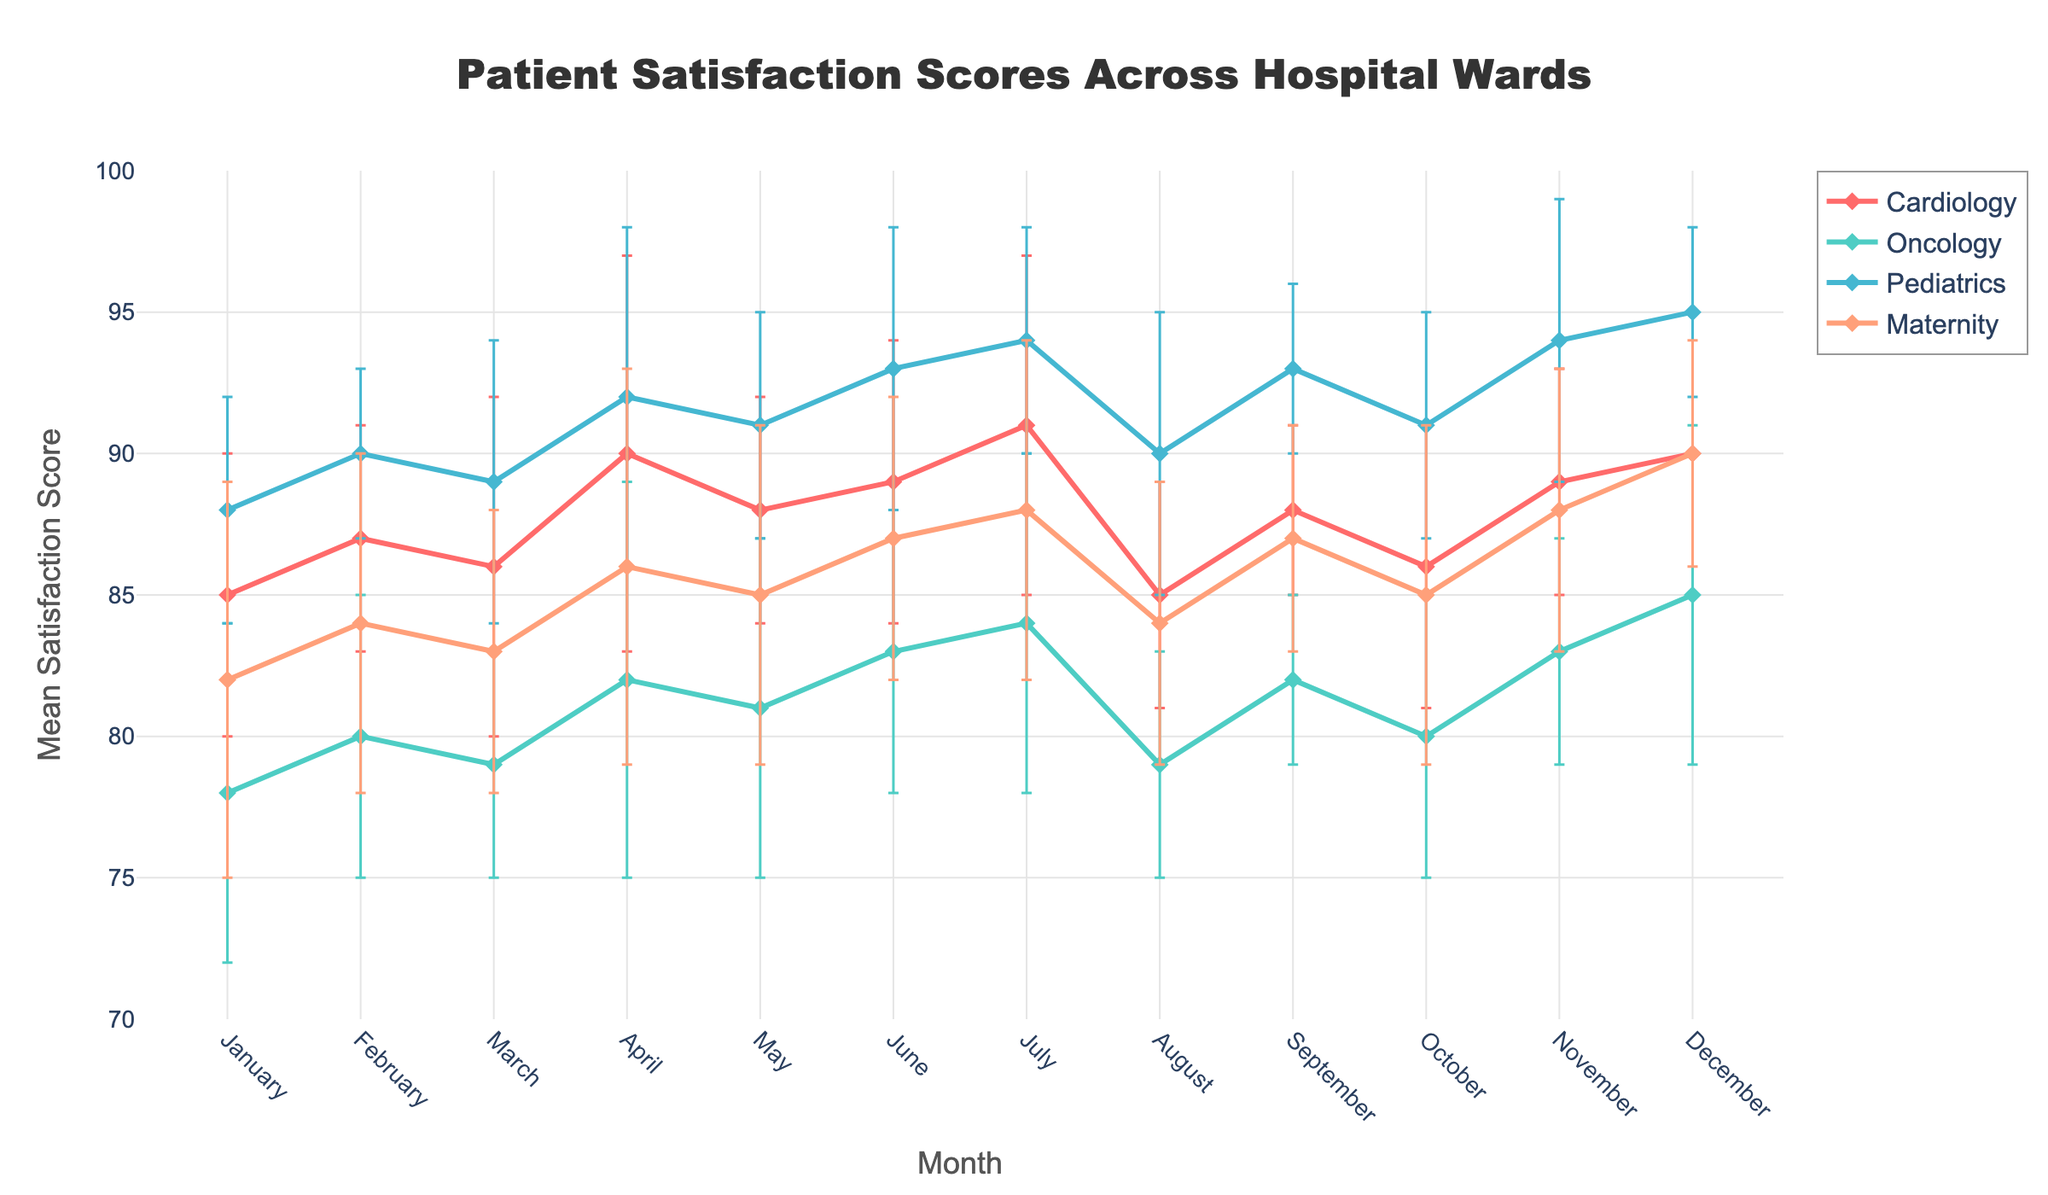Which ward has the highest mean satisfaction score in December? The figure clearly shows the mean satisfaction scores across different wards for each month. For December, compare the mean satisfaction scores for Cardiology, Oncology, Pediatrics, and Maternity.
Answer: Pediatrics What is the range of the y-axis? The y-axis represents the mean satisfaction score. Checking the y-axis reveals the scale is set from 70 to 100.
Answer: 70 to 100 Does any ward have an increasing trend in satisfaction scores over the months? Looking at the plot lines for each ward, notice the general trend of the satisfaction scores. Pediatrics and Maternity both show an upward trend throughout the year.
Answer: Pediatrics, Maternity Which month does Cardiology have the highest mean satisfaction score, and what is it? Observe the data points for Cardiology across all months. The highest point for mean satisfaction in Cardiology occurs in July, with a score of 91.
Answer: July, 91 Compare the mean satisfaction scores for Oncology and Maternity in April. Which ward has a higher score? Find the data points for Oncology and Maternity in April. Oncology has a score of 82, while Maternity has a score of 86.
Answer: Maternity What is the standard deviation for Pediatrics in September? Locate the error bar for Pediatrics in September. The length of the error bar corresponds to the standard deviation, which is 3 in this case.
Answer: 3 Which ward shows the greatest variability in satisfaction scores in January, and what is the standard deviation? Examine the lengths of the error bars for all wards in January. The longest error bar indicates the greatest variability. Maternity has the greatest variability with a standard deviation of 7.
Answer: Maternity, 7 Calculate the average mean satisfaction score for Maternity over the year. Sum the mean satisfaction scores of Maternity for each month and divide by 12: (82+84+83+86+85+87+88+84+87+85+88+90) / 12 = 86.
Answer: 86 Is there any overlap in the error bars of Cardiology and Pediatrics in any month? If so, in which month(s)? Review the error bars for Cardiology and Pediatrics each month to see if they overlap. They overlap in August and October.
Answer: August, October 